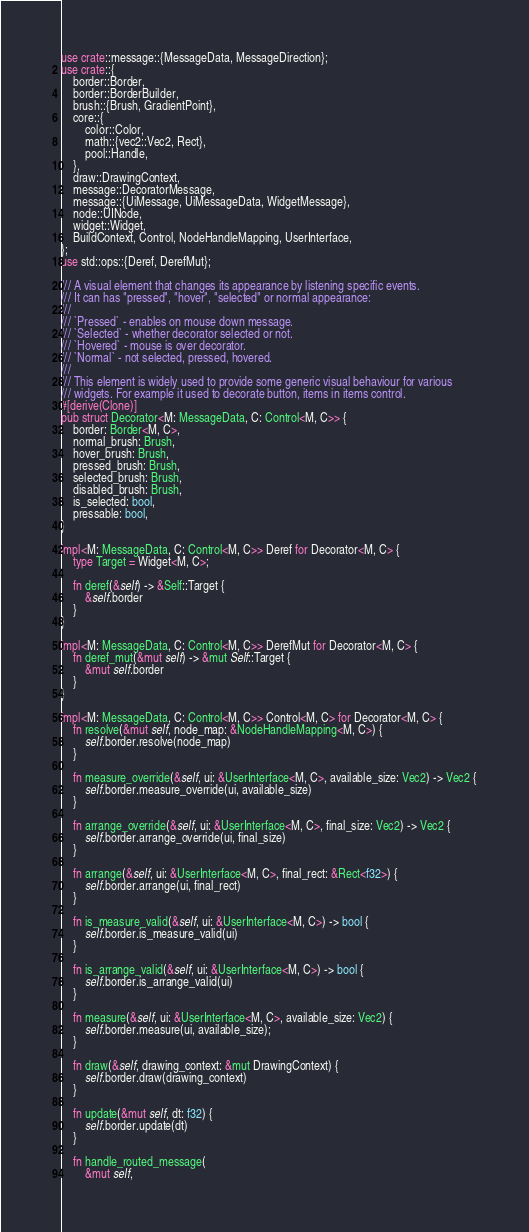Convert code to text. <code><loc_0><loc_0><loc_500><loc_500><_Rust_>use crate::message::{MessageData, MessageDirection};
use crate::{
    border::Border,
    border::BorderBuilder,
    brush::{Brush, GradientPoint},
    core::{
        color::Color,
        math::{vec2::Vec2, Rect},
        pool::Handle,
    },
    draw::DrawingContext,
    message::DecoratorMessage,
    message::{UiMessage, UiMessageData, WidgetMessage},
    node::UINode,
    widget::Widget,
    BuildContext, Control, NodeHandleMapping, UserInterface,
};
use std::ops::{Deref, DerefMut};

/// A visual element that changes its appearance by listening specific events.
/// It can has "pressed", "hover", "selected" or normal appearance:
///
/// `Pressed` - enables on mouse down message.
/// `Selected` - whether decorator selected or not.
/// `Hovered` - mouse is over decorator.
/// `Normal` - not selected, pressed, hovered.
///
/// This element is widely used to provide some generic visual behaviour for various
/// widgets. For example it used to decorate button, items in items control.
#[derive(Clone)]
pub struct Decorator<M: MessageData, C: Control<M, C>> {
    border: Border<M, C>,
    normal_brush: Brush,
    hover_brush: Brush,
    pressed_brush: Brush,
    selected_brush: Brush,
    disabled_brush: Brush,
    is_selected: bool,
    pressable: bool,
}

impl<M: MessageData, C: Control<M, C>> Deref for Decorator<M, C> {
    type Target = Widget<M, C>;

    fn deref(&self) -> &Self::Target {
        &self.border
    }
}

impl<M: MessageData, C: Control<M, C>> DerefMut for Decorator<M, C> {
    fn deref_mut(&mut self) -> &mut Self::Target {
        &mut self.border
    }
}

impl<M: MessageData, C: Control<M, C>> Control<M, C> for Decorator<M, C> {
    fn resolve(&mut self, node_map: &NodeHandleMapping<M, C>) {
        self.border.resolve(node_map)
    }

    fn measure_override(&self, ui: &UserInterface<M, C>, available_size: Vec2) -> Vec2 {
        self.border.measure_override(ui, available_size)
    }

    fn arrange_override(&self, ui: &UserInterface<M, C>, final_size: Vec2) -> Vec2 {
        self.border.arrange_override(ui, final_size)
    }

    fn arrange(&self, ui: &UserInterface<M, C>, final_rect: &Rect<f32>) {
        self.border.arrange(ui, final_rect)
    }

    fn is_measure_valid(&self, ui: &UserInterface<M, C>) -> bool {
        self.border.is_measure_valid(ui)
    }

    fn is_arrange_valid(&self, ui: &UserInterface<M, C>) -> bool {
        self.border.is_arrange_valid(ui)
    }

    fn measure(&self, ui: &UserInterface<M, C>, available_size: Vec2) {
        self.border.measure(ui, available_size);
    }

    fn draw(&self, drawing_context: &mut DrawingContext) {
        self.border.draw(drawing_context)
    }

    fn update(&mut self, dt: f32) {
        self.border.update(dt)
    }

    fn handle_routed_message(
        &mut self,</code> 